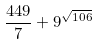<formula> <loc_0><loc_0><loc_500><loc_500>\frac { 4 4 9 } { 7 } + 9 ^ { \sqrt { 1 0 6 } }</formula> 